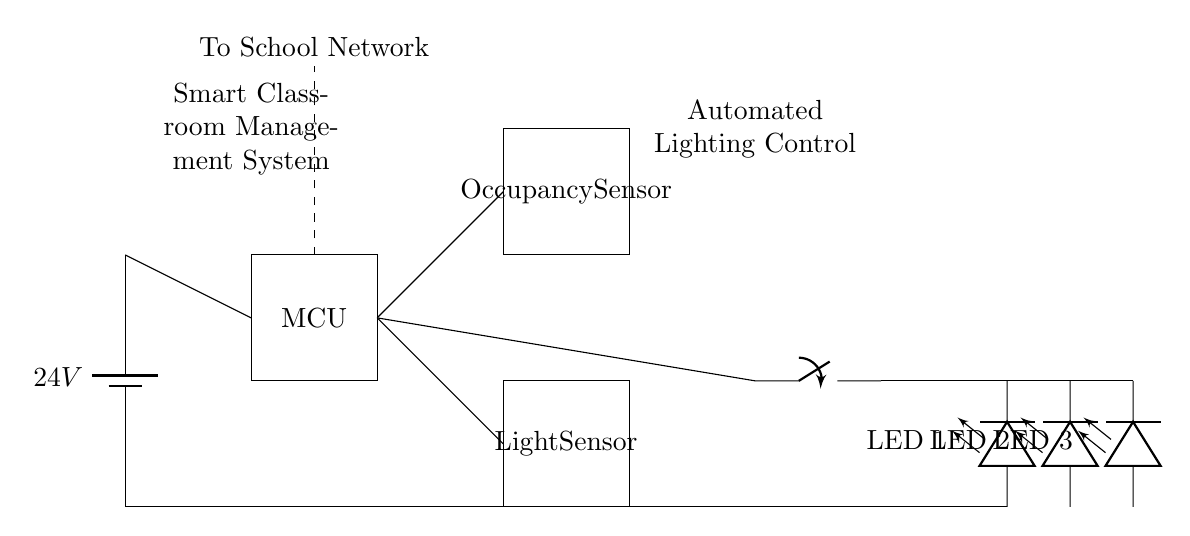What is the voltage of the main power supply? The diagram shows a battery labeled with a potential difference of 24 volts, indicating that this is the voltage supplied to the circuit.
Answer: 24 volts What components are used in this circuit? By examining the circuit diagram, we can identify the major components: a microcontroller, an occupancy sensor, a light sensor, a relay, and LED lights.
Answer: Microcontroller, occupancy sensor, light sensor, relay, LED lights How many LED lights are present in this circuit? The diagram clearly shows three LED lights connected in series. Counting them yields a total of three LED lights.
Answer: Three What is the function of the occupancy sensor in this circuit? The occupancy sensor detects the presence of individuals in the classroom. This information is crucial as it influences whether the lights are turned on or off based on occupancy.
Answer: Detects presence Explain how the lighting is controlled in this system. Lighting is controlled through the occupancy sensor and light sensor. When the occupancy sensor detects movement or presence, it signals the relay to turn on the lights, unless the light sensor detects sufficient ambient light, which would keep the lights off. This intelligent control saves energy when the classroom is unoccupied or well-lit.
Answer: Through occupancy and light sensors What is the purpose of the relay in this circuit? The relay serves as a switch that responds to signals from the microcontroller, allowing it to control the higher power needed to turn on or off the LED lights without directly consuming power from the microcontroller.
Answer: To control LED lights What type of classroom environment does this circuit aim to manage? The components and automation features suggest that this system is designed for a smart classroom, enhancing learning environments through effective occupancy and lighting management for energy efficiency and comfort.
Answer: Smart classroom 